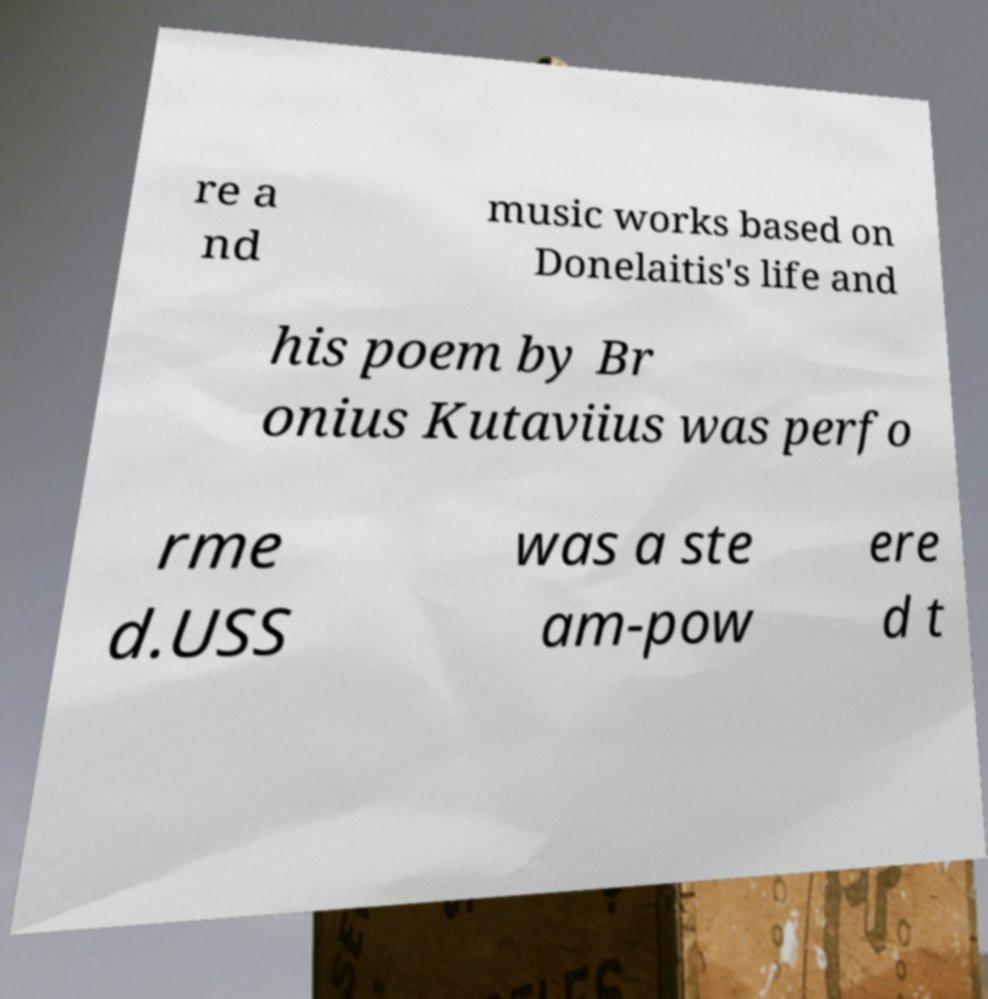Please read and relay the text visible in this image. What does it say? re a nd music works based on Donelaitis's life and his poem by Br onius Kutaviius was perfo rme d.USS was a ste am-pow ere d t 